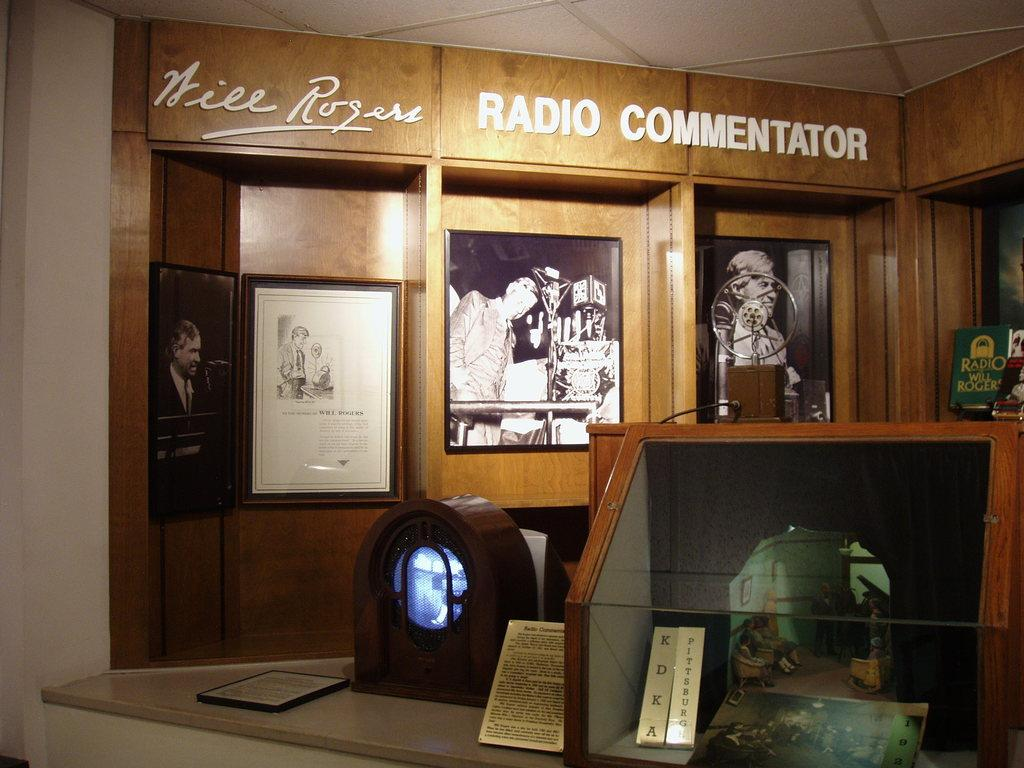<image>
Summarize the visual content of the image. A display commemorating Will Rogers shows photos and awards. 